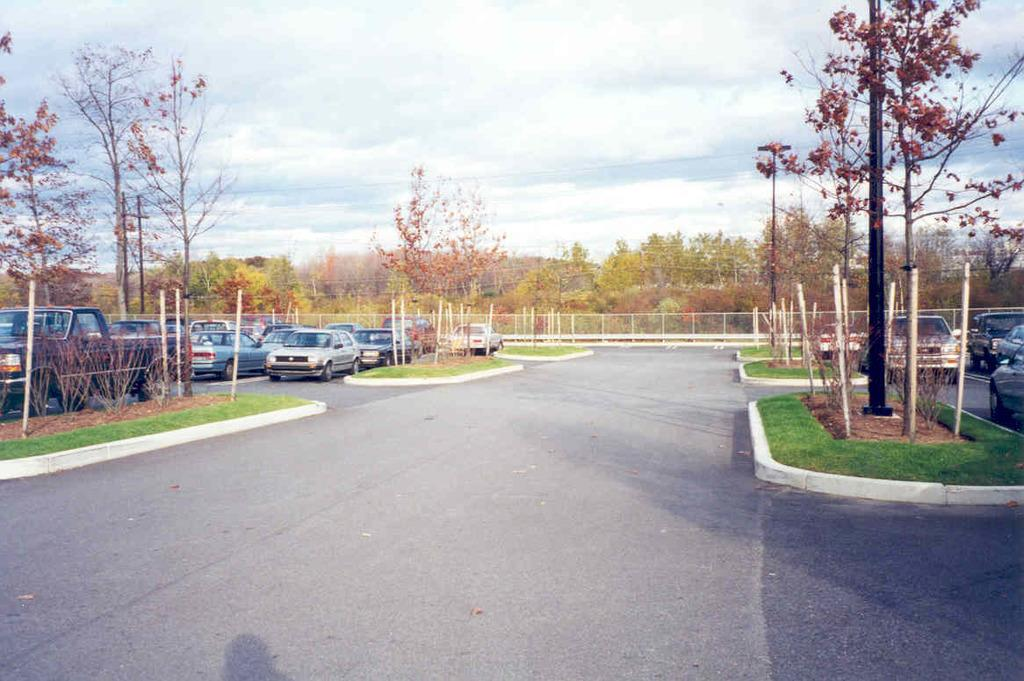What can be seen on the road in the image? There are vehicles on the road in the image. What is visible in the background of the image? There are trees, poles, and a fence in the background of the image. What else can be seen in the image? There are wires visible in the image. What is visible at the top of the image? There are clouds in the sky at the top of the image. Where is the downtown market located in the image? There is no downtown market present in the image. What type of party is being held in the background of the image? There is no party visible in the image; it features vehicles on the road, trees, poles, a fence, wires, and clouds in the sky. 